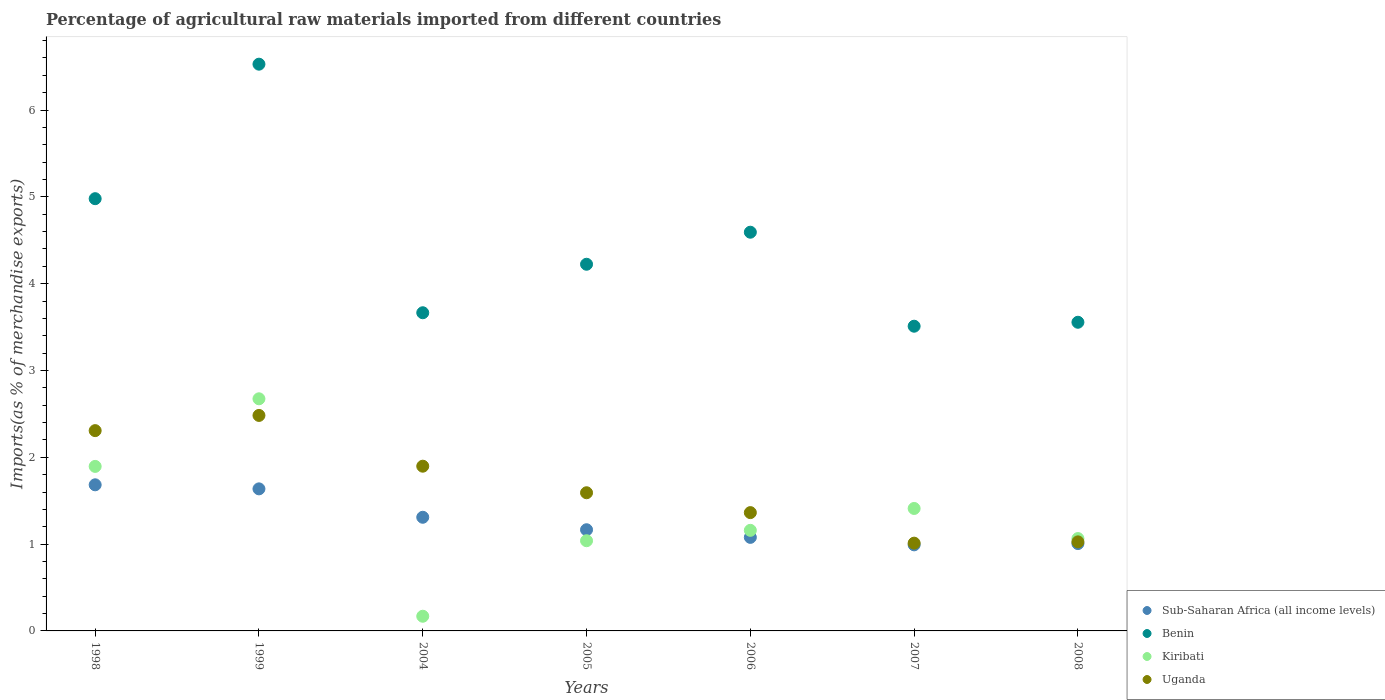Is the number of dotlines equal to the number of legend labels?
Your response must be concise. Yes. What is the percentage of imports to different countries in Benin in 2005?
Ensure brevity in your answer.  4.22. Across all years, what is the maximum percentage of imports to different countries in Kiribati?
Your answer should be very brief. 2.67. Across all years, what is the minimum percentage of imports to different countries in Uganda?
Offer a very short reply. 1.01. What is the total percentage of imports to different countries in Uganda in the graph?
Your answer should be compact. 11.68. What is the difference between the percentage of imports to different countries in Benin in 1998 and that in 2007?
Give a very brief answer. 1.47. What is the difference between the percentage of imports to different countries in Benin in 1998 and the percentage of imports to different countries in Sub-Saharan Africa (all income levels) in 1999?
Provide a succinct answer. 3.34. What is the average percentage of imports to different countries in Sub-Saharan Africa (all income levels) per year?
Your answer should be compact. 1.27. In the year 2007, what is the difference between the percentage of imports to different countries in Kiribati and percentage of imports to different countries in Sub-Saharan Africa (all income levels)?
Your answer should be very brief. 0.42. What is the ratio of the percentage of imports to different countries in Benin in 2007 to that in 2008?
Make the answer very short. 0.99. What is the difference between the highest and the second highest percentage of imports to different countries in Benin?
Ensure brevity in your answer.  1.55. What is the difference between the highest and the lowest percentage of imports to different countries in Kiribati?
Your response must be concise. 2.5. In how many years, is the percentage of imports to different countries in Benin greater than the average percentage of imports to different countries in Benin taken over all years?
Keep it short and to the point. 3. Is the sum of the percentage of imports to different countries in Benin in 2006 and 2008 greater than the maximum percentage of imports to different countries in Sub-Saharan Africa (all income levels) across all years?
Provide a succinct answer. Yes. Is it the case that in every year, the sum of the percentage of imports to different countries in Uganda and percentage of imports to different countries in Kiribati  is greater than the sum of percentage of imports to different countries in Benin and percentage of imports to different countries in Sub-Saharan Africa (all income levels)?
Give a very brief answer. No. Is it the case that in every year, the sum of the percentage of imports to different countries in Benin and percentage of imports to different countries in Kiribati  is greater than the percentage of imports to different countries in Sub-Saharan Africa (all income levels)?
Keep it short and to the point. Yes. Does the percentage of imports to different countries in Sub-Saharan Africa (all income levels) monotonically increase over the years?
Your answer should be very brief. No. How many years are there in the graph?
Your response must be concise. 7. Are the values on the major ticks of Y-axis written in scientific E-notation?
Give a very brief answer. No. Does the graph contain any zero values?
Ensure brevity in your answer.  No. Does the graph contain grids?
Ensure brevity in your answer.  No. Where does the legend appear in the graph?
Give a very brief answer. Bottom right. How many legend labels are there?
Ensure brevity in your answer.  4. What is the title of the graph?
Provide a short and direct response. Percentage of agricultural raw materials imported from different countries. Does "Burkina Faso" appear as one of the legend labels in the graph?
Your answer should be very brief. No. What is the label or title of the X-axis?
Offer a terse response. Years. What is the label or title of the Y-axis?
Your response must be concise. Imports(as % of merchandise exports). What is the Imports(as % of merchandise exports) in Sub-Saharan Africa (all income levels) in 1998?
Your response must be concise. 1.68. What is the Imports(as % of merchandise exports) in Benin in 1998?
Offer a very short reply. 4.98. What is the Imports(as % of merchandise exports) in Kiribati in 1998?
Provide a succinct answer. 1.89. What is the Imports(as % of merchandise exports) of Uganda in 1998?
Offer a very short reply. 2.31. What is the Imports(as % of merchandise exports) in Sub-Saharan Africa (all income levels) in 1999?
Your answer should be compact. 1.64. What is the Imports(as % of merchandise exports) in Benin in 1999?
Ensure brevity in your answer.  6.53. What is the Imports(as % of merchandise exports) of Kiribati in 1999?
Ensure brevity in your answer.  2.67. What is the Imports(as % of merchandise exports) in Uganda in 1999?
Your answer should be compact. 2.48. What is the Imports(as % of merchandise exports) of Sub-Saharan Africa (all income levels) in 2004?
Keep it short and to the point. 1.31. What is the Imports(as % of merchandise exports) in Benin in 2004?
Offer a very short reply. 3.66. What is the Imports(as % of merchandise exports) in Kiribati in 2004?
Your answer should be compact. 0.17. What is the Imports(as % of merchandise exports) of Uganda in 2004?
Make the answer very short. 1.9. What is the Imports(as % of merchandise exports) in Sub-Saharan Africa (all income levels) in 2005?
Your answer should be very brief. 1.17. What is the Imports(as % of merchandise exports) in Benin in 2005?
Your answer should be compact. 4.22. What is the Imports(as % of merchandise exports) in Kiribati in 2005?
Your answer should be compact. 1.04. What is the Imports(as % of merchandise exports) in Uganda in 2005?
Keep it short and to the point. 1.59. What is the Imports(as % of merchandise exports) of Sub-Saharan Africa (all income levels) in 2006?
Your response must be concise. 1.08. What is the Imports(as % of merchandise exports) in Benin in 2006?
Offer a very short reply. 4.59. What is the Imports(as % of merchandise exports) of Kiribati in 2006?
Your answer should be very brief. 1.16. What is the Imports(as % of merchandise exports) in Uganda in 2006?
Give a very brief answer. 1.36. What is the Imports(as % of merchandise exports) in Sub-Saharan Africa (all income levels) in 2007?
Ensure brevity in your answer.  0.99. What is the Imports(as % of merchandise exports) of Benin in 2007?
Your response must be concise. 3.51. What is the Imports(as % of merchandise exports) in Kiribati in 2007?
Your answer should be compact. 1.41. What is the Imports(as % of merchandise exports) of Uganda in 2007?
Ensure brevity in your answer.  1.01. What is the Imports(as % of merchandise exports) in Sub-Saharan Africa (all income levels) in 2008?
Provide a succinct answer. 1.01. What is the Imports(as % of merchandise exports) of Benin in 2008?
Keep it short and to the point. 3.56. What is the Imports(as % of merchandise exports) of Kiribati in 2008?
Offer a terse response. 1.06. What is the Imports(as % of merchandise exports) of Uganda in 2008?
Keep it short and to the point. 1.03. Across all years, what is the maximum Imports(as % of merchandise exports) of Sub-Saharan Africa (all income levels)?
Provide a short and direct response. 1.68. Across all years, what is the maximum Imports(as % of merchandise exports) in Benin?
Keep it short and to the point. 6.53. Across all years, what is the maximum Imports(as % of merchandise exports) of Kiribati?
Your response must be concise. 2.67. Across all years, what is the maximum Imports(as % of merchandise exports) of Uganda?
Your answer should be very brief. 2.48. Across all years, what is the minimum Imports(as % of merchandise exports) of Sub-Saharan Africa (all income levels)?
Keep it short and to the point. 0.99. Across all years, what is the minimum Imports(as % of merchandise exports) of Benin?
Your answer should be very brief. 3.51. Across all years, what is the minimum Imports(as % of merchandise exports) in Kiribati?
Keep it short and to the point. 0.17. Across all years, what is the minimum Imports(as % of merchandise exports) of Uganda?
Your answer should be compact. 1.01. What is the total Imports(as % of merchandise exports) of Sub-Saharan Africa (all income levels) in the graph?
Provide a short and direct response. 8.87. What is the total Imports(as % of merchandise exports) in Benin in the graph?
Ensure brevity in your answer.  31.05. What is the total Imports(as % of merchandise exports) of Kiribati in the graph?
Keep it short and to the point. 9.41. What is the total Imports(as % of merchandise exports) in Uganda in the graph?
Make the answer very short. 11.68. What is the difference between the Imports(as % of merchandise exports) of Sub-Saharan Africa (all income levels) in 1998 and that in 1999?
Your response must be concise. 0.05. What is the difference between the Imports(as % of merchandise exports) in Benin in 1998 and that in 1999?
Your answer should be very brief. -1.55. What is the difference between the Imports(as % of merchandise exports) in Kiribati in 1998 and that in 1999?
Make the answer very short. -0.78. What is the difference between the Imports(as % of merchandise exports) in Uganda in 1998 and that in 1999?
Keep it short and to the point. -0.17. What is the difference between the Imports(as % of merchandise exports) in Sub-Saharan Africa (all income levels) in 1998 and that in 2004?
Your answer should be compact. 0.37. What is the difference between the Imports(as % of merchandise exports) of Benin in 1998 and that in 2004?
Give a very brief answer. 1.31. What is the difference between the Imports(as % of merchandise exports) of Kiribati in 1998 and that in 2004?
Offer a terse response. 1.73. What is the difference between the Imports(as % of merchandise exports) in Uganda in 1998 and that in 2004?
Ensure brevity in your answer.  0.41. What is the difference between the Imports(as % of merchandise exports) of Sub-Saharan Africa (all income levels) in 1998 and that in 2005?
Provide a succinct answer. 0.52. What is the difference between the Imports(as % of merchandise exports) of Benin in 1998 and that in 2005?
Keep it short and to the point. 0.76. What is the difference between the Imports(as % of merchandise exports) of Kiribati in 1998 and that in 2005?
Your answer should be very brief. 0.86. What is the difference between the Imports(as % of merchandise exports) in Uganda in 1998 and that in 2005?
Your answer should be very brief. 0.72. What is the difference between the Imports(as % of merchandise exports) in Sub-Saharan Africa (all income levels) in 1998 and that in 2006?
Keep it short and to the point. 0.61. What is the difference between the Imports(as % of merchandise exports) of Benin in 1998 and that in 2006?
Provide a succinct answer. 0.39. What is the difference between the Imports(as % of merchandise exports) in Kiribati in 1998 and that in 2006?
Ensure brevity in your answer.  0.74. What is the difference between the Imports(as % of merchandise exports) in Uganda in 1998 and that in 2006?
Offer a very short reply. 0.94. What is the difference between the Imports(as % of merchandise exports) in Sub-Saharan Africa (all income levels) in 1998 and that in 2007?
Ensure brevity in your answer.  0.69. What is the difference between the Imports(as % of merchandise exports) of Benin in 1998 and that in 2007?
Provide a short and direct response. 1.47. What is the difference between the Imports(as % of merchandise exports) in Kiribati in 1998 and that in 2007?
Make the answer very short. 0.48. What is the difference between the Imports(as % of merchandise exports) of Uganda in 1998 and that in 2007?
Offer a terse response. 1.3. What is the difference between the Imports(as % of merchandise exports) of Sub-Saharan Africa (all income levels) in 1998 and that in 2008?
Your answer should be compact. 0.68. What is the difference between the Imports(as % of merchandise exports) in Benin in 1998 and that in 2008?
Your answer should be compact. 1.42. What is the difference between the Imports(as % of merchandise exports) of Kiribati in 1998 and that in 2008?
Keep it short and to the point. 0.83. What is the difference between the Imports(as % of merchandise exports) of Uganda in 1998 and that in 2008?
Make the answer very short. 1.28. What is the difference between the Imports(as % of merchandise exports) in Sub-Saharan Africa (all income levels) in 1999 and that in 2004?
Your answer should be very brief. 0.33. What is the difference between the Imports(as % of merchandise exports) of Benin in 1999 and that in 2004?
Offer a terse response. 2.86. What is the difference between the Imports(as % of merchandise exports) of Kiribati in 1999 and that in 2004?
Your answer should be very brief. 2.5. What is the difference between the Imports(as % of merchandise exports) of Uganda in 1999 and that in 2004?
Your answer should be very brief. 0.58. What is the difference between the Imports(as % of merchandise exports) of Sub-Saharan Africa (all income levels) in 1999 and that in 2005?
Offer a terse response. 0.47. What is the difference between the Imports(as % of merchandise exports) in Benin in 1999 and that in 2005?
Offer a very short reply. 2.3. What is the difference between the Imports(as % of merchandise exports) in Kiribati in 1999 and that in 2005?
Offer a very short reply. 1.63. What is the difference between the Imports(as % of merchandise exports) of Uganda in 1999 and that in 2005?
Provide a short and direct response. 0.89. What is the difference between the Imports(as % of merchandise exports) in Sub-Saharan Africa (all income levels) in 1999 and that in 2006?
Provide a succinct answer. 0.56. What is the difference between the Imports(as % of merchandise exports) of Benin in 1999 and that in 2006?
Your answer should be very brief. 1.94. What is the difference between the Imports(as % of merchandise exports) of Kiribati in 1999 and that in 2006?
Your answer should be compact. 1.52. What is the difference between the Imports(as % of merchandise exports) in Uganda in 1999 and that in 2006?
Provide a short and direct response. 1.12. What is the difference between the Imports(as % of merchandise exports) in Sub-Saharan Africa (all income levels) in 1999 and that in 2007?
Offer a very short reply. 0.64. What is the difference between the Imports(as % of merchandise exports) in Benin in 1999 and that in 2007?
Offer a very short reply. 3.02. What is the difference between the Imports(as % of merchandise exports) of Kiribati in 1999 and that in 2007?
Provide a succinct answer. 1.26. What is the difference between the Imports(as % of merchandise exports) in Uganda in 1999 and that in 2007?
Offer a terse response. 1.47. What is the difference between the Imports(as % of merchandise exports) in Sub-Saharan Africa (all income levels) in 1999 and that in 2008?
Provide a short and direct response. 0.63. What is the difference between the Imports(as % of merchandise exports) in Benin in 1999 and that in 2008?
Your response must be concise. 2.97. What is the difference between the Imports(as % of merchandise exports) in Kiribati in 1999 and that in 2008?
Keep it short and to the point. 1.61. What is the difference between the Imports(as % of merchandise exports) in Uganda in 1999 and that in 2008?
Your answer should be compact. 1.46. What is the difference between the Imports(as % of merchandise exports) of Sub-Saharan Africa (all income levels) in 2004 and that in 2005?
Your response must be concise. 0.14. What is the difference between the Imports(as % of merchandise exports) of Benin in 2004 and that in 2005?
Provide a short and direct response. -0.56. What is the difference between the Imports(as % of merchandise exports) of Kiribati in 2004 and that in 2005?
Make the answer very short. -0.87. What is the difference between the Imports(as % of merchandise exports) of Uganda in 2004 and that in 2005?
Ensure brevity in your answer.  0.31. What is the difference between the Imports(as % of merchandise exports) of Sub-Saharan Africa (all income levels) in 2004 and that in 2006?
Give a very brief answer. 0.23. What is the difference between the Imports(as % of merchandise exports) of Benin in 2004 and that in 2006?
Your answer should be compact. -0.93. What is the difference between the Imports(as % of merchandise exports) of Kiribati in 2004 and that in 2006?
Provide a succinct answer. -0.99. What is the difference between the Imports(as % of merchandise exports) of Uganda in 2004 and that in 2006?
Provide a short and direct response. 0.53. What is the difference between the Imports(as % of merchandise exports) in Sub-Saharan Africa (all income levels) in 2004 and that in 2007?
Offer a terse response. 0.32. What is the difference between the Imports(as % of merchandise exports) of Benin in 2004 and that in 2007?
Give a very brief answer. 0.16. What is the difference between the Imports(as % of merchandise exports) of Kiribati in 2004 and that in 2007?
Your answer should be very brief. -1.24. What is the difference between the Imports(as % of merchandise exports) in Uganda in 2004 and that in 2007?
Your answer should be compact. 0.89. What is the difference between the Imports(as % of merchandise exports) in Sub-Saharan Africa (all income levels) in 2004 and that in 2008?
Your answer should be compact. 0.3. What is the difference between the Imports(as % of merchandise exports) in Benin in 2004 and that in 2008?
Provide a succinct answer. 0.11. What is the difference between the Imports(as % of merchandise exports) of Kiribati in 2004 and that in 2008?
Ensure brevity in your answer.  -0.89. What is the difference between the Imports(as % of merchandise exports) in Uganda in 2004 and that in 2008?
Ensure brevity in your answer.  0.87. What is the difference between the Imports(as % of merchandise exports) of Sub-Saharan Africa (all income levels) in 2005 and that in 2006?
Ensure brevity in your answer.  0.09. What is the difference between the Imports(as % of merchandise exports) in Benin in 2005 and that in 2006?
Offer a terse response. -0.37. What is the difference between the Imports(as % of merchandise exports) in Kiribati in 2005 and that in 2006?
Your answer should be very brief. -0.12. What is the difference between the Imports(as % of merchandise exports) in Uganda in 2005 and that in 2006?
Offer a very short reply. 0.23. What is the difference between the Imports(as % of merchandise exports) of Sub-Saharan Africa (all income levels) in 2005 and that in 2007?
Offer a very short reply. 0.17. What is the difference between the Imports(as % of merchandise exports) of Benin in 2005 and that in 2007?
Offer a very short reply. 0.71. What is the difference between the Imports(as % of merchandise exports) in Kiribati in 2005 and that in 2007?
Provide a short and direct response. -0.37. What is the difference between the Imports(as % of merchandise exports) in Uganda in 2005 and that in 2007?
Your response must be concise. 0.58. What is the difference between the Imports(as % of merchandise exports) in Sub-Saharan Africa (all income levels) in 2005 and that in 2008?
Offer a very short reply. 0.16. What is the difference between the Imports(as % of merchandise exports) of Benin in 2005 and that in 2008?
Offer a terse response. 0.67. What is the difference between the Imports(as % of merchandise exports) of Kiribati in 2005 and that in 2008?
Make the answer very short. -0.03. What is the difference between the Imports(as % of merchandise exports) of Uganda in 2005 and that in 2008?
Your answer should be compact. 0.57. What is the difference between the Imports(as % of merchandise exports) in Sub-Saharan Africa (all income levels) in 2006 and that in 2007?
Your answer should be very brief. 0.09. What is the difference between the Imports(as % of merchandise exports) in Benin in 2006 and that in 2007?
Make the answer very short. 1.08. What is the difference between the Imports(as % of merchandise exports) of Kiribati in 2006 and that in 2007?
Your response must be concise. -0.25. What is the difference between the Imports(as % of merchandise exports) of Uganda in 2006 and that in 2007?
Give a very brief answer. 0.35. What is the difference between the Imports(as % of merchandise exports) in Sub-Saharan Africa (all income levels) in 2006 and that in 2008?
Your answer should be very brief. 0.07. What is the difference between the Imports(as % of merchandise exports) of Benin in 2006 and that in 2008?
Provide a succinct answer. 1.04. What is the difference between the Imports(as % of merchandise exports) in Kiribati in 2006 and that in 2008?
Keep it short and to the point. 0.09. What is the difference between the Imports(as % of merchandise exports) in Uganda in 2006 and that in 2008?
Provide a short and direct response. 0.34. What is the difference between the Imports(as % of merchandise exports) in Sub-Saharan Africa (all income levels) in 2007 and that in 2008?
Provide a short and direct response. -0.01. What is the difference between the Imports(as % of merchandise exports) of Benin in 2007 and that in 2008?
Offer a very short reply. -0.05. What is the difference between the Imports(as % of merchandise exports) in Kiribati in 2007 and that in 2008?
Keep it short and to the point. 0.35. What is the difference between the Imports(as % of merchandise exports) of Uganda in 2007 and that in 2008?
Provide a succinct answer. -0.01. What is the difference between the Imports(as % of merchandise exports) of Sub-Saharan Africa (all income levels) in 1998 and the Imports(as % of merchandise exports) of Benin in 1999?
Offer a very short reply. -4.84. What is the difference between the Imports(as % of merchandise exports) of Sub-Saharan Africa (all income levels) in 1998 and the Imports(as % of merchandise exports) of Kiribati in 1999?
Your response must be concise. -0.99. What is the difference between the Imports(as % of merchandise exports) of Sub-Saharan Africa (all income levels) in 1998 and the Imports(as % of merchandise exports) of Uganda in 1999?
Offer a terse response. -0.8. What is the difference between the Imports(as % of merchandise exports) in Benin in 1998 and the Imports(as % of merchandise exports) in Kiribati in 1999?
Your response must be concise. 2.31. What is the difference between the Imports(as % of merchandise exports) of Benin in 1998 and the Imports(as % of merchandise exports) of Uganda in 1999?
Provide a succinct answer. 2.5. What is the difference between the Imports(as % of merchandise exports) in Kiribati in 1998 and the Imports(as % of merchandise exports) in Uganda in 1999?
Offer a very short reply. -0.59. What is the difference between the Imports(as % of merchandise exports) of Sub-Saharan Africa (all income levels) in 1998 and the Imports(as % of merchandise exports) of Benin in 2004?
Provide a short and direct response. -1.98. What is the difference between the Imports(as % of merchandise exports) of Sub-Saharan Africa (all income levels) in 1998 and the Imports(as % of merchandise exports) of Kiribati in 2004?
Provide a succinct answer. 1.51. What is the difference between the Imports(as % of merchandise exports) in Sub-Saharan Africa (all income levels) in 1998 and the Imports(as % of merchandise exports) in Uganda in 2004?
Ensure brevity in your answer.  -0.21. What is the difference between the Imports(as % of merchandise exports) of Benin in 1998 and the Imports(as % of merchandise exports) of Kiribati in 2004?
Provide a short and direct response. 4.81. What is the difference between the Imports(as % of merchandise exports) in Benin in 1998 and the Imports(as % of merchandise exports) in Uganda in 2004?
Offer a terse response. 3.08. What is the difference between the Imports(as % of merchandise exports) in Kiribati in 1998 and the Imports(as % of merchandise exports) in Uganda in 2004?
Your answer should be compact. -0. What is the difference between the Imports(as % of merchandise exports) of Sub-Saharan Africa (all income levels) in 1998 and the Imports(as % of merchandise exports) of Benin in 2005?
Offer a very short reply. -2.54. What is the difference between the Imports(as % of merchandise exports) in Sub-Saharan Africa (all income levels) in 1998 and the Imports(as % of merchandise exports) in Kiribati in 2005?
Give a very brief answer. 0.64. What is the difference between the Imports(as % of merchandise exports) in Sub-Saharan Africa (all income levels) in 1998 and the Imports(as % of merchandise exports) in Uganda in 2005?
Your response must be concise. 0.09. What is the difference between the Imports(as % of merchandise exports) of Benin in 1998 and the Imports(as % of merchandise exports) of Kiribati in 2005?
Make the answer very short. 3.94. What is the difference between the Imports(as % of merchandise exports) in Benin in 1998 and the Imports(as % of merchandise exports) in Uganda in 2005?
Provide a short and direct response. 3.39. What is the difference between the Imports(as % of merchandise exports) of Kiribati in 1998 and the Imports(as % of merchandise exports) of Uganda in 2005?
Offer a terse response. 0.3. What is the difference between the Imports(as % of merchandise exports) in Sub-Saharan Africa (all income levels) in 1998 and the Imports(as % of merchandise exports) in Benin in 2006?
Your answer should be very brief. -2.91. What is the difference between the Imports(as % of merchandise exports) of Sub-Saharan Africa (all income levels) in 1998 and the Imports(as % of merchandise exports) of Kiribati in 2006?
Give a very brief answer. 0.52. What is the difference between the Imports(as % of merchandise exports) of Sub-Saharan Africa (all income levels) in 1998 and the Imports(as % of merchandise exports) of Uganda in 2006?
Provide a succinct answer. 0.32. What is the difference between the Imports(as % of merchandise exports) in Benin in 1998 and the Imports(as % of merchandise exports) in Kiribati in 2006?
Make the answer very short. 3.82. What is the difference between the Imports(as % of merchandise exports) of Benin in 1998 and the Imports(as % of merchandise exports) of Uganda in 2006?
Your answer should be very brief. 3.62. What is the difference between the Imports(as % of merchandise exports) of Kiribati in 1998 and the Imports(as % of merchandise exports) of Uganda in 2006?
Your response must be concise. 0.53. What is the difference between the Imports(as % of merchandise exports) of Sub-Saharan Africa (all income levels) in 1998 and the Imports(as % of merchandise exports) of Benin in 2007?
Ensure brevity in your answer.  -1.83. What is the difference between the Imports(as % of merchandise exports) of Sub-Saharan Africa (all income levels) in 1998 and the Imports(as % of merchandise exports) of Kiribati in 2007?
Ensure brevity in your answer.  0.27. What is the difference between the Imports(as % of merchandise exports) of Sub-Saharan Africa (all income levels) in 1998 and the Imports(as % of merchandise exports) of Uganda in 2007?
Your response must be concise. 0.67. What is the difference between the Imports(as % of merchandise exports) of Benin in 1998 and the Imports(as % of merchandise exports) of Kiribati in 2007?
Keep it short and to the point. 3.57. What is the difference between the Imports(as % of merchandise exports) of Benin in 1998 and the Imports(as % of merchandise exports) of Uganda in 2007?
Keep it short and to the point. 3.97. What is the difference between the Imports(as % of merchandise exports) in Kiribati in 1998 and the Imports(as % of merchandise exports) in Uganda in 2007?
Offer a terse response. 0.88. What is the difference between the Imports(as % of merchandise exports) of Sub-Saharan Africa (all income levels) in 1998 and the Imports(as % of merchandise exports) of Benin in 2008?
Provide a short and direct response. -1.87. What is the difference between the Imports(as % of merchandise exports) in Sub-Saharan Africa (all income levels) in 1998 and the Imports(as % of merchandise exports) in Kiribati in 2008?
Your response must be concise. 0.62. What is the difference between the Imports(as % of merchandise exports) of Sub-Saharan Africa (all income levels) in 1998 and the Imports(as % of merchandise exports) of Uganda in 2008?
Give a very brief answer. 0.66. What is the difference between the Imports(as % of merchandise exports) in Benin in 1998 and the Imports(as % of merchandise exports) in Kiribati in 2008?
Your response must be concise. 3.91. What is the difference between the Imports(as % of merchandise exports) of Benin in 1998 and the Imports(as % of merchandise exports) of Uganda in 2008?
Give a very brief answer. 3.95. What is the difference between the Imports(as % of merchandise exports) of Kiribati in 1998 and the Imports(as % of merchandise exports) of Uganda in 2008?
Make the answer very short. 0.87. What is the difference between the Imports(as % of merchandise exports) of Sub-Saharan Africa (all income levels) in 1999 and the Imports(as % of merchandise exports) of Benin in 2004?
Make the answer very short. -2.03. What is the difference between the Imports(as % of merchandise exports) of Sub-Saharan Africa (all income levels) in 1999 and the Imports(as % of merchandise exports) of Kiribati in 2004?
Provide a short and direct response. 1.47. What is the difference between the Imports(as % of merchandise exports) in Sub-Saharan Africa (all income levels) in 1999 and the Imports(as % of merchandise exports) in Uganda in 2004?
Keep it short and to the point. -0.26. What is the difference between the Imports(as % of merchandise exports) in Benin in 1999 and the Imports(as % of merchandise exports) in Kiribati in 2004?
Provide a short and direct response. 6.36. What is the difference between the Imports(as % of merchandise exports) in Benin in 1999 and the Imports(as % of merchandise exports) in Uganda in 2004?
Provide a succinct answer. 4.63. What is the difference between the Imports(as % of merchandise exports) of Kiribati in 1999 and the Imports(as % of merchandise exports) of Uganda in 2004?
Offer a terse response. 0.78. What is the difference between the Imports(as % of merchandise exports) of Sub-Saharan Africa (all income levels) in 1999 and the Imports(as % of merchandise exports) of Benin in 2005?
Your response must be concise. -2.59. What is the difference between the Imports(as % of merchandise exports) of Sub-Saharan Africa (all income levels) in 1999 and the Imports(as % of merchandise exports) of Kiribati in 2005?
Your answer should be compact. 0.6. What is the difference between the Imports(as % of merchandise exports) in Sub-Saharan Africa (all income levels) in 1999 and the Imports(as % of merchandise exports) in Uganda in 2005?
Ensure brevity in your answer.  0.04. What is the difference between the Imports(as % of merchandise exports) in Benin in 1999 and the Imports(as % of merchandise exports) in Kiribati in 2005?
Make the answer very short. 5.49. What is the difference between the Imports(as % of merchandise exports) of Benin in 1999 and the Imports(as % of merchandise exports) of Uganda in 2005?
Your answer should be compact. 4.94. What is the difference between the Imports(as % of merchandise exports) of Kiribati in 1999 and the Imports(as % of merchandise exports) of Uganda in 2005?
Keep it short and to the point. 1.08. What is the difference between the Imports(as % of merchandise exports) in Sub-Saharan Africa (all income levels) in 1999 and the Imports(as % of merchandise exports) in Benin in 2006?
Provide a short and direct response. -2.96. What is the difference between the Imports(as % of merchandise exports) in Sub-Saharan Africa (all income levels) in 1999 and the Imports(as % of merchandise exports) in Kiribati in 2006?
Offer a terse response. 0.48. What is the difference between the Imports(as % of merchandise exports) in Sub-Saharan Africa (all income levels) in 1999 and the Imports(as % of merchandise exports) in Uganda in 2006?
Give a very brief answer. 0.27. What is the difference between the Imports(as % of merchandise exports) of Benin in 1999 and the Imports(as % of merchandise exports) of Kiribati in 2006?
Provide a succinct answer. 5.37. What is the difference between the Imports(as % of merchandise exports) of Benin in 1999 and the Imports(as % of merchandise exports) of Uganda in 2006?
Your answer should be very brief. 5.17. What is the difference between the Imports(as % of merchandise exports) of Kiribati in 1999 and the Imports(as % of merchandise exports) of Uganda in 2006?
Provide a succinct answer. 1.31. What is the difference between the Imports(as % of merchandise exports) in Sub-Saharan Africa (all income levels) in 1999 and the Imports(as % of merchandise exports) in Benin in 2007?
Ensure brevity in your answer.  -1.87. What is the difference between the Imports(as % of merchandise exports) of Sub-Saharan Africa (all income levels) in 1999 and the Imports(as % of merchandise exports) of Kiribati in 2007?
Provide a succinct answer. 0.23. What is the difference between the Imports(as % of merchandise exports) in Sub-Saharan Africa (all income levels) in 1999 and the Imports(as % of merchandise exports) in Uganda in 2007?
Provide a short and direct response. 0.63. What is the difference between the Imports(as % of merchandise exports) in Benin in 1999 and the Imports(as % of merchandise exports) in Kiribati in 2007?
Your response must be concise. 5.12. What is the difference between the Imports(as % of merchandise exports) of Benin in 1999 and the Imports(as % of merchandise exports) of Uganda in 2007?
Provide a short and direct response. 5.52. What is the difference between the Imports(as % of merchandise exports) in Kiribati in 1999 and the Imports(as % of merchandise exports) in Uganda in 2007?
Make the answer very short. 1.66. What is the difference between the Imports(as % of merchandise exports) of Sub-Saharan Africa (all income levels) in 1999 and the Imports(as % of merchandise exports) of Benin in 2008?
Provide a succinct answer. -1.92. What is the difference between the Imports(as % of merchandise exports) of Sub-Saharan Africa (all income levels) in 1999 and the Imports(as % of merchandise exports) of Kiribati in 2008?
Provide a succinct answer. 0.57. What is the difference between the Imports(as % of merchandise exports) in Sub-Saharan Africa (all income levels) in 1999 and the Imports(as % of merchandise exports) in Uganda in 2008?
Offer a very short reply. 0.61. What is the difference between the Imports(as % of merchandise exports) in Benin in 1999 and the Imports(as % of merchandise exports) in Kiribati in 2008?
Ensure brevity in your answer.  5.46. What is the difference between the Imports(as % of merchandise exports) in Benin in 1999 and the Imports(as % of merchandise exports) in Uganda in 2008?
Give a very brief answer. 5.5. What is the difference between the Imports(as % of merchandise exports) of Kiribati in 1999 and the Imports(as % of merchandise exports) of Uganda in 2008?
Your answer should be compact. 1.65. What is the difference between the Imports(as % of merchandise exports) in Sub-Saharan Africa (all income levels) in 2004 and the Imports(as % of merchandise exports) in Benin in 2005?
Your answer should be compact. -2.91. What is the difference between the Imports(as % of merchandise exports) in Sub-Saharan Africa (all income levels) in 2004 and the Imports(as % of merchandise exports) in Kiribati in 2005?
Provide a short and direct response. 0.27. What is the difference between the Imports(as % of merchandise exports) of Sub-Saharan Africa (all income levels) in 2004 and the Imports(as % of merchandise exports) of Uganda in 2005?
Offer a very short reply. -0.28. What is the difference between the Imports(as % of merchandise exports) of Benin in 2004 and the Imports(as % of merchandise exports) of Kiribati in 2005?
Make the answer very short. 2.63. What is the difference between the Imports(as % of merchandise exports) in Benin in 2004 and the Imports(as % of merchandise exports) in Uganda in 2005?
Offer a very short reply. 2.07. What is the difference between the Imports(as % of merchandise exports) of Kiribati in 2004 and the Imports(as % of merchandise exports) of Uganda in 2005?
Your response must be concise. -1.42. What is the difference between the Imports(as % of merchandise exports) in Sub-Saharan Africa (all income levels) in 2004 and the Imports(as % of merchandise exports) in Benin in 2006?
Your response must be concise. -3.28. What is the difference between the Imports(as % of merchandise exports) of Sub-Saharan Africa (all income levels) in 2004 and the Imports(as % of merchandise exports) of Kiribati in 2006?
Offer a terse response. 0.15. What is the difference between the Imports(as % of merchandise exports) of Sub-Saharan Africa (all income levels) in 2004 and the Imports(as % of merchandise exports) of Uganda in 2006?
Your answer should be very brief. -0.05. What is the difference between the Imports(as % of merchandise exports) of Benin in 2004 and the Imports(as % of merchandise exports) of Kiribati in 2006?
Offer a terse response. 2.51. What is the difference between the Imports(as % of merchandise exports) in Benin in 2004 and the Imports(as % of merchandise exports) in Uganda in 2006?
Make the answer very short. 2.3. What is the difference between the Imports(as % of merchandise exports) in Kiribati in 2004 and the Imports(as % of merchandise exports) in Uganda in 2006?
Provide a succinct answer. -1.19. What is the difference between the Imports(as % of merchandise exports) of Sub-Saharan Africa (all income levels) in 2004 and the Imports(as % of merchandise exports) of Benin in 2007?
Give a very brief answer. -2.2. What is the difference between the Imports(as % of merchandise exports) of Sub-Saharan Africa (all income levels) in 2004 and the Imports(as % of merchandise exports) of Kiribati in 2007?
Make the answer very short. -0.1. What is the difference between the Imports(as % of merchandise exports) of Sub-Saharan Africa (all income levels) in 2004 and the Imports(as % of merchandise exports) of Uganda in 2007?
Provide a succinct answer. 0.3. What is the difference between the Imports(as % of merchandise exports) in Benin in 2004 and the Imports(as % of merchandise exports) in Kiribati in 2007?
Your response must be concise. 2.25. What is the difference between the Imports(as % of merchandise exports) of Benin in 2004 and the Imports(as % of merchandise exports) of Uganda in 2007?
Provide a succinct answer. 2.65. What is the difference between the Imports(as % of merchandise exports) of Kiribati in 2004 and the Imports(as % of merchandise exports) of Uganda in 2007?
Provide a succinct answer. -0.84. What is the difference between the Imports(as % of merchandise exports) in Sub-Saharan Africa (all income levels) in 2004 and the Imports(as % of merchandise exports) in Benin in 2008?
Keep it short and to the point. -2.25. What is the difference between the Imports(as % of merchandise exports) in Sub-Saharan Africa (all income levels) in 2004 and the Imports(as % of merchandise exports) in Kiribati in 2008?
Provide a succinct answer. 0.25. What is the difference between the Imports(as % of merchandise exports) in Sub-Saharan Africa (all income levels) in 2004 and the Imports(as % of merchandise exports) in Uganda in 2008?
Provide a short and direct response. 0.28. What is the difference between the Imports(as % of merchandise exports) in Benin in 2004 and the Imports(as % of merchandise exports) in Kiribati in 2008?
Your answer should be very brief. 2.6. What is the difference between the Imports(as % of merchandise exports) of Benin in 2004 and the Imports(as % of merchandise exports) of Uganda in 2008?
Provide a succinct answer. 2.64. What is the difference between the Imports(as % of merchandise exports) in Kiribati in 2004 and the Imports(as % of merchandise exports) in Uganda in 2008?
Keep it short and to the point. -0.86. What is the difference between the Imports(as % of merchandise exports) in Sub-Saharan Africa (all income levels) in 2005 and the Imports(as % of merchandise exports) in Benin in 2006?
Keep it short and to the point. -3.43. What is the difference between the Imports(as % of merchandise exports) in Sub-Saharan Africa (all income levels) in 2005 and the Imports(as % of merchandise exports) in Kiribati in 2006?
Your response must be concise. 0.01. What is the difference between the Imports(as % of merchandise exports) in Sub-Saharan Africa (all income levels) in 2005 and the Imports(as % of merchandise exports) in Uganda in 2006?
Give a very brief answer. -0.2. What is the difference between the Imports(as % of merchandise exports) of Benin in 2005 and the Imports(as % of merchandise exports) of Kiribati in 2006?
Give a very brief answer. 3.06. What is the difference between the Imports(as % of merchandise exports) of Benin in 2005 and the Imports(as % of merchandise exports) of Uganda in 2006?
Provide a short and direct response. 2.86. What is the difference between the Imports(as % of merchandise exports) in Kiribati in 2005 and the Imports(as % of merchandise exports) in Uganda in 2006?
Provide a short and direct response. -0.32. What is the difference between the Imports(as % of merchandise exports) in Sub-Saharan Africa (all income levels) in 2005 and the Imports(as % of merchandise exports) in Benin in 2007?
Ensure brevity in your answer.  -2.34. What is the difference between the Imports(as % of merchandise exports) of Sub-Saharan Africa (all income levels) in 2005 and the Imports(as % of merchandise exports) of Kiribati in 2007?
Make the answer very short. -0.25. What is the difference between the Imports(as % of merchandise exports) in Sub-Saharan Africa (all income levels) in 2005 and the Imports(as % of merchandise exports) in Uganda in 2007?
Your answer should be compact. 0.15. What is the difference between the Imports(as % of merchandise exports) in Benin in 2005 and the Imports(as % of merchandise exports) in Kiribati in 2007?
Offer a terse response. 2.81. What is the difference between the Imports(as % of merchandise exports) of Benin in 2005 and the Imports(as % of merchandise exports) of Uganda in 2007?
Keep it short and to the point. 3.21. What is the difference between the Imports(as % of merchandise exports) in Kiribati in 2005 and the Imports(as % of merchandise exports) in Uganda in 2007?
Offer a very short reply. 0.03. What is the difference between the Imports(as % of merchandise exports) in Sub-Saharan Africa (all income levels) in 2005 and the Imports(as % of merchandise exports) in Benin in 2008?
Your answer should be very brief. -2.39. What is the difference between the Imports(as % of merchandise exports) of Sub-Saharan Africa (all income levels) in 2005 and the Imports(as % of merchandise exports) of Kiribati in 2008?
Provide a succinct answer. 0.1. What is the difference between the Imports(as % of merchandise exports) in Sub-Saharan Africa (all income levels) in 2005 and the Imports(as % of merchandise exports) in Uganda in 2008?
Provide a short and direct response. 0.14. What is the difference between the Imports(as % of merchandise exports) in Benin in 2005 and the Imports(as % of merchandise exports) in Kiribati in 2008?
Provide a succinct answer. 3.16. What is the difference between the Imports(as % of merchandise exports) in Benin in 2005 and the Imports(as % of merchandise exports) in Uganda in 2008?
Make the answer very short. 3.2. What is the difference between the Imports(as % of merchandise exports) of Kiribati in 2005 and the Imports(as % of merchandise exports) of Uganda in 2008?
Provide a short and direct response. 0.01. What is the difference between the Imports(as % of merchandise exports) of Sub-Saharan Africa (all income levels) in 2006 and the Imports(as % of merchandise exports) of Benin in 2007?
Keep it short and to the point. -2.43. What is the difference between the Imports(as % of merchandise exports) in Sub-Saharan Africa (all income levels) in 2006 and the Imports(as % of merchandise exports) in Kiribati in 2007?
Make the answer very short. -0.33. What is the difference between the Imports(as % of merchandise exports) in Sub-Saharan Africa (all income levels) in 2006 and the Imports(as % of merchandise exports) in Uganda in 2007?
Provide a short and direct response. 0.07. What is the difference between the Imports(as % of merchandise exports) in Benin in 2006 and the Imports(as % of merchandise exports) in Kiribati in 2007?
Ensure brevity in your answer.  3.18. What is the difference between the Imports(as % of merchandise exports) of Benin in 2006 and the Imports(as % of merchandise exports) of Uganda in 2007?
Make the answer very short. 3.58. What is the difference between the Imports(as % of merchandise exports) in Kiribati in 2006 and the Imports(as % of merchandise exports) in Uganda in 2007?
Your response must be concise. 0.15. What is the difference between the Imports(as % of merchandise exports) in Sub-Saharan Africa (all income levels) in 2006 and the Imports(as % of merchandise exports) in Benin in 2008?
Provide a succinct answer. -2.48. What is the difference between the Imports(as % of merchandise exports) of Sub-Saharan Africa (all income levels) in 2006 and the Imports(as % of merchandise exports) of Kiribati in 2008?
Offer a terse response. 0.01. What is the difference between the Imports(as % of merchandise exports) in Sub-Saharan Africa (all income levels) in 2006 and the Imports(as % of merchandise exports) in Uganda in 2008?
Offer a terse response. 0.05. What is the difference between the Imports(as % of merchandise exports) of Benin in 2006 and the Imports(as % of merchandise exports) of Kiribati in 2008?
Ensure brevity in your answer.  3.53. What is the difference between the Imports(as % of merchandise exports) in Benin in 2006 and the Imports(as % of merchandise exports) in Uganda in 2008?
Ensure brevity in your answer.  3.57. What is the difference between the Imports(as % of merchandise exports) of Kiribati in 2006 and the Imports(as % of merchandise exports) of Uganda in 2008?
Provide a succinct answer. 0.13. What is the difference between the Imports(as % of merchandise exports) in Sub-Saharan Africa (all income levels) in 2007 and the Imports(as % of merchandise exports) in Benin in 2008?
Offer a terse response. -2.56. What is the difference between the Imports(as % of merchandise exports) in Sub-Saharan Africa (all income levels) in 2007 and the Imports(as % of merchandise exports) in Kiribati in 2008?
Provide a succinct answer. -0.07. What is the difference between the Imports(as % of merchandise exports) in Sub-Saharan Africa (all income levels) in 2007 and the Imports(as % of merchandise exports) in Uganda in 2008?
Offer a very short reply. -0.03. What is the difference between the Imports(as % of merchandise exports) of Benin in 2007 and the Imports(as % of merchandise exports) of Kiribati in 2008?
Make the answer very short. 2.45. What is the difference between the Imports(as % of merchandise exports) of Benin in 2007 and the Imports(as % of merchandise exports) of Uganda in 2008?
Keep it short and to the point. 2.48. What is the difference between the Imports(as % of merchandise exports) in Kiribati in 2007 and the Imports(as % of merchandise exports) in Uganda in 2008?
Your answer should be compact. 0.38. What is the average Imports(as % of merchandise exports) in Sub-Saharan Africa (all income levels) per year?
Your answer should be very brief. 1.27. What is the average Imports(as % of merchandise exports) of Benin per year?
Offer a very short reply. 4.44. What is the average Imports(as % of merchandise exports) in Kiribati per year?
Your answer should be very brief. 1.34. What is the average Imports(as % of merchandise exports) of Uganda per year?
Give a very brief answer. 1.67. In the year 1998, what is the difference between the Imports(as % of merchandise exports) of Sub-Saharan Africa (all income levels) and Imports(as % of merchandise exports) of Benin?
Keep it short and to the point. -3.3. In the year 1998, what is the difference between the Imports(as % of merchandise exports) of Sub-Saharan Africa (all income levels) and Imports(as % of merchandise exports) of Kiribati?
Your answer should be compact. -0.21. In the year 1998, what is the difference between the Imports(as % of merchandise exports) of Sub-Saharan Africa (all income levels) and Imports(as % of merchandise exports) of Uganda?
Your answer should be compact. -0.62. In the year 1998, what is the difference between the Imports(as % of merchandise exports) of Benin and Imports(as % of merchandise exports) of Kiribati?
Your answer should be very brief. 3.08. In the year 1998, what is the difference between the Imports(as % of merchandise exports) of Benin and Imports(as % of merchandise exports) of Uganda?
Your answer should be very brief. 2.67. In the year 1998, what is the difference between the Imports(as % of merchandise exports) in Kiribati and Imports(as % of merchandise exports) in Uganda?
Offer a terse response. -0.41. In the year 1999, what is the difference between the Imports(as % of merchandise exports) of Sub-Saharan Africa (all income levels) and Imports(as % of merchandise exports) of Benin?
Provide a succinct answer. -4.89. In the year 1999, what is the difference between the Imports(as % of merchandise exports) of Sub-Saharan Africa (all income levels) and Imports(as % of merchandise exports) of Kiribati?
Your answer should be compact. -1.04. In the year 1999, what is the difference between the Imports(as % of merchandise exports) of Sub-Saharan Africa (all income levels) and Imports(as % of merchandise exports) of Uganda?
Provide a short and direct response. -0.85. In the year 1999, what is the difference between the Imports(as % of merchandise exports) of Benin and Imports(as % of merchandise exports) of Kiribati?
Your response must be concise. 3.85. In the year 1999, what is the difference between the Imports(as % of merchandise exports) of Benin and Imports(as % of merchandise exports) of Uganda?
Keep it short and to the point. 4.05. In the year 1999, what is the difference between the Imports(as % of merchandise exports) of Kiribati and Imports(as % of merchandise exports) of Uganda?
Your answer should be very brief. 0.19. In the year 2004, what is the difference between the Imports(as % of merchandise exports) in Sub-Saharan Africa (all income levels) and Imports(as % of merchandise exports) in Benin?
Your answer should be compact. -2.36. In the year 2004, what is the difference between the Imports(as % of merchandise exports) of Sub-Saharan Africa (all income levels) and Imports(as % of merchandise exports) of Kiribati?
Your answer should be very brief. 1.14. In the year 2004, what is the difference between the Imports(as % of merchandise exports) of Sub-Saharan Africa (all income levels) and Imports(as % of merchandise exports) of Uganda?
Give a very brief answer. -0.59. In the year 2004, what is the difference between the Imports(as % of merchandise exports) in Benin and Imports(as % of merchandise exports) in Kiribati?
Make the answer very short. 3.5. In the year 2004, what is the difference between the Imports(as % of merchandise exports) of Benin and Imports(as % of merchandise exports) of Uganda?
Your answer should be compact. 1.77. In the year 2004, what is the difference between the Imports(as % of merchandise exports) of Kiribati and Imports(as % of merchandise exports) of Uganda?
Provide a succinct answer. -1.73. In the year 2005, what is the difference between the Imports(as % of merchandise exports) of Sub-Saharan Africa (all income levels) and Imports(as % of merchandise exports) of Benin?
Your answer should be very brief. -3.06. In the year 2005, what is the difference between the Imports(as % of merchandise exports) of Sub-Saharan Africa (all income levels) and Imports(as % of merchandise exports) of Kiribati?
Keep it short and to the point. 0.13. In the year 2005, what is the difference between the Imports(as % of merchandise exports) in Sub-Saharan Africa (all income levels) and Imports(as % of merchandise exports) in Uganda?
Ensure brevity in your answer.  -0.43. In the year 2005, what is the difference between the Imports(as % of merchandise exports) in Benin and Imports(as % of merchandise exports) in Kiribati?
Make the answer very short. 3.18. In the year 2005, what is the difference between the Imports(as % of merchandise exports) of Benin and Imports(as % of merchandise exports) of Uganda?
Your answer should be compact. 2.63. In the year 2005, what is the difference between the Imports(as % of merchandise exports) of Kiribati and Imports(as % of merchandise exports) of Uganda?
Provide a short and direct response. -0.55. In the year 2006, what is the difference between the Imports(as % of merchandise exports) in Sub-Saharan Africa (all income levels) and Imports(as % of merchandise exports) in Benin?
Offer a terse response. -3.51. In the year 2006, what is the difference between the Imports(as % of merchandise exports) of Sub-Saharan Africa (all income levels) and Imports(as % of merchandise exports) of Kiribati?
Provide a succinct answer. -0.08. In the year 2006, what is the difference between the Imports(as % of merchandise exports) in Sub-Saharan Africa (all income levels) and Imports(as % of merchandise exports) in Uganda?
Make the answer very short. -0.29. In the year 2006, what is the difference between the Imports(as % of merchandise exports) in Benin and Imports(as % of merchandise exports) in Kiribati?
Provide a short and direct response. 3.43. In the year 2006, what is the difference between the Imports(as % of merchandise exports) in Benin and Imports(as % of merchandise exports) in Uganda?
Offer a very short reply. 3.23. In the year 2006, what is the difference between the Imports(as % of merchandise exports) in Kiribati and Imports(as % of merchandise exports) in Uganda?
Make the answer very short. -0.2. In the year 2007, what is the difference between the Imports(as % of merchandise exports) in Sub-Saharan Africa (all income levels) and Imports(as % of merchandise exports) in Benin?
Keep it short and to the point. -2.52. In the year 2007, what is the difference between the Imports(as % of merchandise exports) of Sub-Saharan Africa (all income levels) and Imports(as % of merchandise exports) of Kiribati?
Make the answer very short. -0.42. In the year 2007, what is the difference between the Imports(as % of merchandise exports) in Sub-Saharan Africa (all income levels) and Imports(as % of merchandise exports) in Uganda?
Give a very brief answer. -0.02. In the year 2007, what is the difference between the Imports(as % of merchandise exports) in Benin and Imports(as % of merchandise exports) in Kiribati?
Offer a terse response. 2.1. In the year 2007, what is the difference between the Imports(as % of merchandise exports) of Benin and Imports(as % of merchandise exports) of Uganda?
Ensure brevity in your answer.  2.5. In the year 2007, what is the difference between the Imports(as % of merchandise exports) of Kiribati and Imports(as % of merchandise exports) of Uganda?
Keep it short and to the point. 0.4. In the year 2008, what is the difference between the Imports(as % of merchandise exports) of Sub-Saharan Africa (all income levels) and Imports(as % of merchandise exports) of Benin?
Offer a very short reply. -2.55. In the year 2008, what is the difference between the Imports(as % of merchandise exports) in Sub-Saharan Africa (all income levels) and Imports(as % of merchandise exports) in Kiribati?
Your answer should be compact. -0.06. In the year 2008, what is the difference between the Imports(as % of merchandise exports) in Sub-Saharan Africa (all income levels) and Imports(as % of merchandise exports) in Uganda?
Ensure brevity in your answer.  -0.02. In the year 2008, what is the difference between the Imports(as % of merchandise exports) in Benin and Imports(as % of merchandise exports) in Kiribati?
Your response must be concise. 2.49. In the year 2008, what is the difference between the Imports(as % of merchandise exports) in Benin and Imports(as % of merchandise exports) in Uganda?
Give a very brief answer. 2.53. In the year 2008, what is the difference between the Imports(as % of merchandise exports) of Kiribati and Imports(as % of merchandise exports) of Uganda?
Offer a terse response. 0.04. What is the ratio of the Imports(as % of merchandise exports) of Sub-Saharan Africa (all income levels) in 1998 to that in 1999?
Provide a short and direct response. 1.03. What is the ratio of the Imports(as % of merchandise exports) in Benin in 1998 to that in 1999?
Keep it short and to the point. 0.76. What is the ratio of the Imports(as % of merchandise exports) of Kiribati in 1998 to that in 1999?
Your response must be concise. 0.71. What is the ratio of the Imports(as % of merchandise exports) in Uganda in 1998 to that in 1999?
Offer a terse response. 0.93. What is the ratio of the Imports(as % of merchandise exports) in Sub-Saharan Africa (all income levels) in 1998 to that in 2004?
Make the answer very short. 1.29. What is the ratio of the Imports(as % of merchandise exports) of Benin in 1998 to that in 2004?
Offer a very short reply. 1.36. What is the ratio of the Imports(as % of merchandise exports) in Kiribati in 1998 to that in 2004?
Give a very brief answer. 11.21. What is the ratio of the Imports(as % of merchandise exports) of Uganda in 1998 to that in 2004?
Offer a very short reply. 1.22. What is the ratio of the Imports(as % of merchandise exports) in Sub-Saharan Africa (all income levels) in 1998 to that in 2005?
Your response must be concise. 1.44. What is the ratio of the Imports(as % of merchandise exports) of Benin in 1998 to that in 2005?
Your response must be concise. 1.18. What is the ratio of the Imports(as % of merchandise exports) of Kiribati in 1998 to that in 2005?
Offer a terse response. 1.82. What is the ratio of the Imports(as % of merchandise exports) of Uganda in 1998 to that in 2005?
Ensure brevity in your answer.  1.45. What is the ratio of the Imports(as % of merchandise exports) in Sub-Saharan Africa (all income levels) in 1998 to that in 2006?
Provide a short and direct response. 1.56. What is the ratio of the Imports(as % of merchandise exports) of Benin in 1998 to that in 2006?
Your answer should be compact. 1.08. What is the ratio of the Imports(as % of merchandise exports) in Kiribati in 1998 to that in 2006?
Your answer should be very brief. 1.64. What is the ratio of the Imports(as % of merchandise exports) of Uganda in 1998 to that in 2006?
Your response must be concise. 1.69. What is the ratio of the Imports(as % of merchandise exports) of Sub-Saharan Africa (all income levels) in 1998 to that in 2007?
Give a very brief answer. 1.7. What is the ratio of the Imports(as % of merchandise exports) of Benin in 1998 to that in 2007?
Your answer should be compact. 1.42. What is the ratio of the Imports(as % of merchandise exports) of Kiribati in 1998 to that in 2007?
Make the answer very short. 1.34. What is the ratio of the Imports(as % of merchandise exports) in Uganda in 1998 to that in 2007?
Offer a very short reply. 2.28. What is the ratio of the Imports(as % of merchandise exports) of Sub-Saharan Africa (all income levels) in 1998 to that in 2008?
Your answer should be compact. 1.67. What is the ratio of the Imports(as % of merchandise exports) of Benin in 1998 to that in 2008?
Give a very brief answer. 1.4. What is the ratio of the Imports(as % of merchandise exports) of Kiribati in 1998 to that in 2008?
Offer a very short reply. 1.78. What is the ratio of the Imports(as % of merchandise exports) of Uganda in 1998 to that in 2008?
Ensure brevity in your answer.  2.25. What is the ratio of the Imports(as % of merchandise exports) of Benin in 1999 to that in 2004?
Your response must be concise. 1.78. What is the ratio of the Imports(as % of merchandise exports) of Kiribati in 1999 to that in 2004?
Offer a terse response. 15.81. What is the ratio of the Imports(as % of merchandise exports) of Uganda in 1999 to that in 2004?
Keep it short and to the point. 1.31. What is the ratio of the Imports(as % of merchandise exports) of Sub-Saharan Africa (all income levels) in 1999 to that in 2005?
Provide a succinct answer. 1.4. What is the ratio of the Imports(as % of merchandise exports) in Benin in 1999 to that in 2005?
Provide a succinct answer. 1.55. What is the ratio of the Imports(as % of merchandise exports) in Kiribati in 1999 to that in 2005?
Offer a very short reply. 2.57. What is the ratio of the Imports(as % of merchandise exports) of Uganda in 1999 to that in 2005?
Offer a terse response. 1.56. What is the ratio of the Imports(as % of merchandise exports) in Sub-Saharan Africa (all income levels) in 1999 to that in 2006?
Offer a terse response. 1.52. What is the ratio of the Imports(as % of merchandise exports) of Benin in 1999 to that in 2006?
Provide a short and direct response. 1.42. What is the ratio of the Imports(as % of merchandise exports) of Kiribati in 1999 to that in 2006?
Your answer should be compact. 2.31. What is the ratio of the Imports(as % of merchandise exports) in Uganda in 1999 to that in 2006?
Provide a short and direct response. 1.82. What is the ratio of the Imports(as % of merchandise exports) in Sub-Saharan Africa (all income levels) in 1999 to that in 2007?
Offer a very short reply. 1.65. What is the ratio of the Imports(as % of merchandise exports) of Benin in 1999 to that in 2007?
Provide a succinct answer. 1.86. What is the ratio of the Imports(as % of merchandise exports) in Kiribati in 1999 to that in 2007?
Your response must be concise. 1.9. What is the ratio of the Imports(as % of merchandise exports) in Uganda in 1999 to that in 2007?
Make the answer very short. 2.46. What is the ratio of the Imports(as % of merchandise exports) of Sub-Saharan Africa (all income levels) in 1999 to that in 2008?
Give a very brief answer. 1.63. What is the ratio of the Imports(as % of merchandise exports) of Benin in 1999 to that in 2008?
Provide a succinct answer. 1.84. What is the ratio of the Imports(as % of merchandise exports) in Kiribati in 1999 to that in 2008?
Give a very brief answer. 2.51. What is the ratio of the Imports(as % of merchandise exports) in Uganda in 1999 to that in 2008?
Offer a terse response. 2.42. What is the ratio of the Imports(as % of merchandise exports) in Sub-Saharan Africa (all income levels) in 2004 to that in 2005?
Give a very brief answer. 1.12. What is the ratio of the Imports(as % of merchandise exports) of Benin in 2004 to that in 2005?
Your answer should be very brief. 0.87. What is the ratio of the Imports(as % of merchandise exports) of Kiribati in 2004 to that in 2005?
Ensure brevity in your answer.  0.16. What is the ratio of the Imports(as % of merchandise exports) in Uganda in 2004 to that in 2005?
Your answer should be compact. 1.19. What is the ratio of the Imports(as % of merchandise exports) of Sub-Saharan Africa (all income levels) in 2004 to that in 2006?
Offer a very short reply. 1.21. What is the ratio of the Imports(as % of merchandise exports) in Benin in 2004 to that in 2006?
Keep it short and to the point. 0.8. What is the ratio of the Imports(as % of merchandise exports) in Kiribati in 2004 to that in 2006?
Give a very brief answer. 0.15. What is the ratio of the Imports(as % of merchandise exports) of Uganda in 2004 to that in 2006?
Provide a succinct answer. 1.39. What is the ratio of the Imports(as % of merchandise exports) in Sub-Saharan Africa (all income levels) in 2004 to that in 2007?
Make the answer very short. 1.32. What is the ratio of the Imports(as % of merchandise exports) in Benin in 2004 to that in 2007?
Provide a succinct answer. 1.04. What is the ratio of the Imports(as % of merchandise exports) in Kiribati in 2004 to that in 2007?
Offer a very short reply. 0.12. What is the ratio of the Imports(as % of merchandise exports) of Uganda in 2004 to that in 2007?
Your answer should be compact. 1.88. What is the ratio of the Imports(as % of merchandise exports) of Sub-Saharan Africa (all income levels) in 2004 to that in 2008?
Make the answer very short. 1.3. What is the ratio of the Imports(as % of merchandise exports) of Benin in 2004 to that in 2008?
Give a very brief answer. 1.03. What is the ratio of the Imports(as % of merchandise exports) of Kiribati in 2004 to that in 2008?
Offer a very short reply. 0.16. What is the ratio of the Imports(as % of merchandise exports) of Uganda in 2004 to that in 2008?
Your answer should be very brief. 1.85. What is the ratio of the Imports(as % of merchandise exports) of Sub-Saharan Africa (all income levels) in 2005 to that in 2006?
Your answer should be compact. 1.08. What is the ratio of the Imports(as % of merchandise exports) in Benin in 2005 to that in 2006?
Provide a succinct answer. 0.92. What is the ratio of the Imports(as % of merchandise exports) in Kiribati in 2005 to that in 2006?
Ensure brevity in your answer.  0.9. What is the ratio of the Imports(as % of merchandise exports) of Uganda in 2005 to that in 2006?
Provide a short and direct response. 1.17. What is the ratio of the Imports(as % of merchandise exports) in Sub-Saharan Africa (all income levels) in 2005 to that in 2007?
Provide a succinct answer. 1.18. What is the ratio of the Imports(as % of merchandise exports) of Benin in 2005 to that in 2007?
Provide a short and direct response. 1.2. What is the ratio of the Imports(as % of merchandise exports) of Kiribati in 2005 to that in 2007?
Keep it short and to the point. 0.74. What is the ratio of the Imports(as % of merchandise exports) of Uganda in 2005 to that in 2007?
Your answer should be compact. 1.57. What is the ratio of the Imports(as % of merchandise exports) in Sub-Saharan Africa (all income levels) in 2005 to that in 2008?
Provide a succinct answer. 1.16. What is the ratio of the Imports(as % of merchandise exports) of Benin in 2005 to that in 2008?
Ensure brevity in your answer.  1.19. What is the ratio of the Imports(as % of merchandise exports) of Kiribati in 2005 to that in 2008?
Your response must be concise. 0.98. What is the ratio of the Imports(as % of merchandise exports) in Uganda in 2005 to that in 2008?
Provide a succinct answer. 1.55. What is the ratio of the Imports(as % of merchandise exports) in Sub-Saharan Africa (all income levels) in 2006 to that in 2007?
Your answer should be compact. 1.09. What is the ratio of the Imports(as % of merchandise exports) in Benin in 2006 to that in 2007?
Ensure brevity in your answer.  1.31. What is the ratio of the Imports(as % of merchandise exports) of Kiribati in 2006 to that in 2007?
Offer a very short reply. 0.82. What is the ratio of the Imports(as % of merchandise exports) in Uganda in 2006 to that in 2007?
Keep it short and to the point. 1.35. What is the ratio of the Imports(as % of merchandise exports) in Sub-Saharan Africa (all income levels) in 2006 to that in 2008?
Keep it short and to the point. 1.07. What is the ratio of the Imports(as % of merchandise exports) in Benin in 2006 to that in 2008?
Your answer should be very brief. 1.29. What is the ratio of the Imports(as % of merchandise exports) of Kiribati in 2006 to that in 2008?
Your answer should be very brief. 1.09. What is the ratio of the Imports(as % of merchandise exports) in Uganda in 2006 to that in 2008?
Provide a succinct answer. 1.33. What is the ratio of the Imports(as % of merchandise exports) of Sub-Saharan Africa (all income levels) in 2007 to that in 2008?
Provide a short and direct response. 0.99. What is the ratio of the Imports(as % of merchandise exports) in Benin in 2007 to that in 2008?
Your answer should be compact. 0.99. What is the ratio of the Imports(as % of merchandise exports) of Kiribati in 2007 to that in 2008?
Keep it short and to the point. 1.33. What is the ratio of the Imports(as % of merchandise exports) in Uganda in 2007 to that in 2008?
Offer a terse response. 0.99. What is the difference between the highest and the second highest Imports(as % of merchandise exports) of Sub-Saharan Africa (all income levels)?
Keep it short and to the point. 0.05. What is the difference between the highest and the second highest Imports(as % of merchandise exports) of Benin?
Keep it short and to the point. 1.55. What is the difference between the highest and the second highest Imports(as % of merchandise exports) of Kiribati?
Ensure brevity in your answer.  0.78. What is the difference between the highest and the second highest Imports(as % of merchandise exports) of Uganda?
Provide a succinct answer. 0.17. What is the difference between the highest and the lowest Imports(as % of merchandise exports) in Sub-Saharan Africa (all income levels)?
Offer a terse response. 0.69. What is the difference between the highest and the lowest Imports(as % of merchandise exports) in Benin?
Offer a terse response. 3.02. What is the difference between the highest and the lowest Imports(as % of merchandise exports) in Kiribati?
Provide a short and direct response. 2.5. What is the difference between the highest and the lowest Imports(as % of merchandise exports) in Uganda?
Your response must be concise. 1.47. 